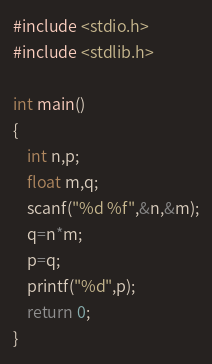Convert code to text. <code><loc_0><loc_0><loc_500><loc_500><_C_>#include <stdio.h>
#include <stdlib.h>

int main()
{
    int n,p;
    float m,q;
    scanf("%d %f",&n,&m);
    q=n*m;
    p=q;
    printf("%d",p);
    return 0;
}</code> 